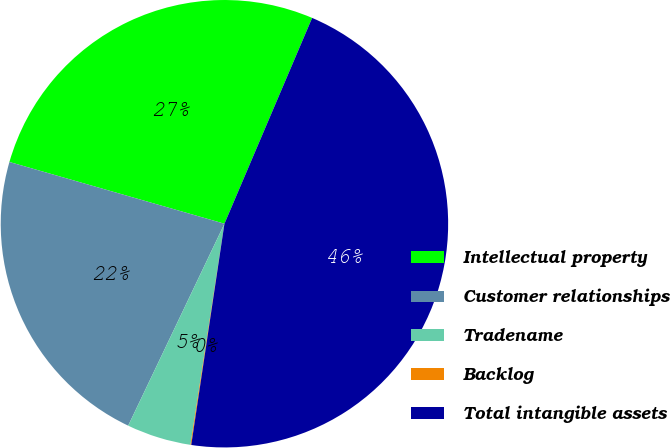Convert chart. <chart><loc_0><loc_0><loc_500><loc_500><pie_chart><fcel>Intellectual property<fcel>Customer relationships<fcel>Tradename<fcel>Backlog<fcel>Total intangible assets<nl><fcel>26.96%<fcel>22.37%<fcel>4.65%<fcel>0.06%<fcel>45.96%<nl></chart> 